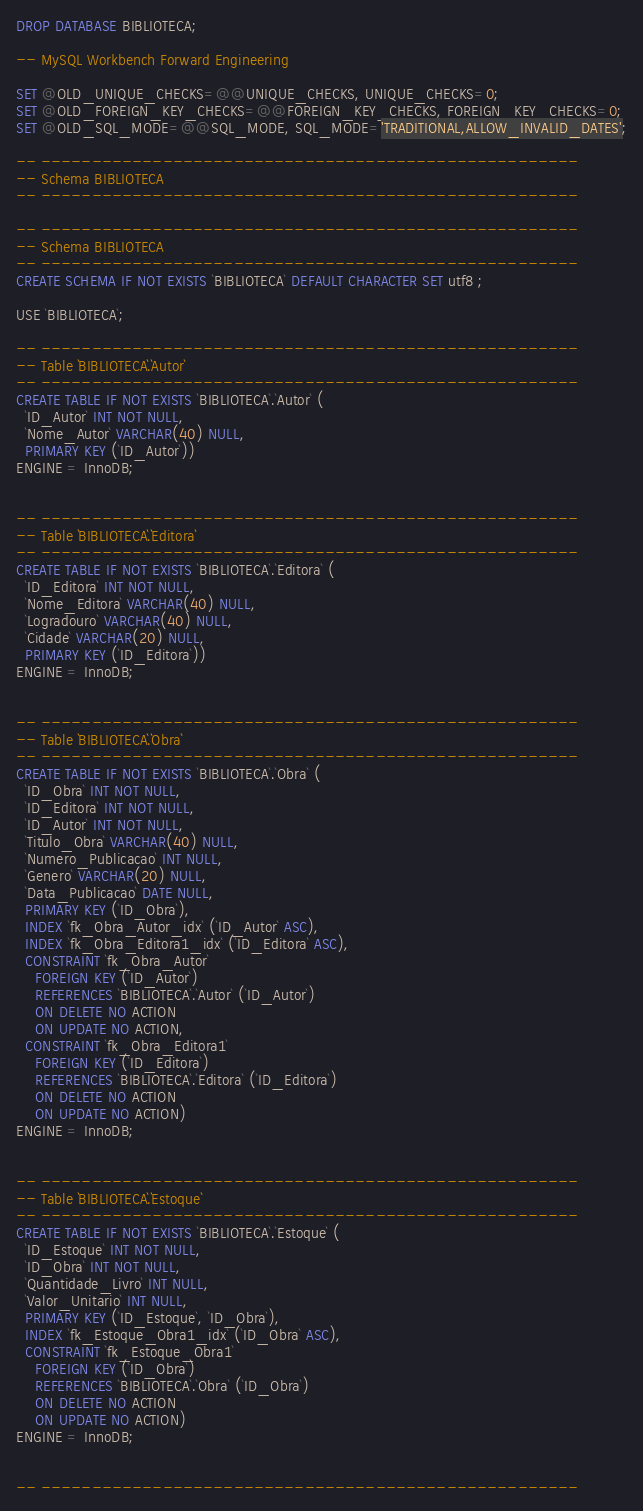Convert code to text. <code><loc_0><loc_0><loc_500><loc_500><_SQL_>DROP DATABASE BIBLIOTECA;

-- MySQL Workbench Forward Engineering

SET @OLD_UNIQUE_CHECKS=@@UNIQUE_CHECKS, UNIQUE_CHECKS=0;
SET @OLD_FOREIGN_KEY_CHECKS=@@FOREIGN_KEY_CHECKS, FOREIGN_KEY_CHECKS=0;
SET @OLD_SQL_MODE=@@SQL_MODE, SQL_MODE='TRADITIONAL,ALLOW_INVALID_DATES';

-- -----------------------------------------------------
-- Schema BIBLIOTECA
-- -----------------------------------------------------

-- -----------------------------------------------------
-- Schema BIBLIOTECA
-- -----------------------------------------------------
CREATE SCHEMA IF NOT EXISTS `BIBLIOTECA` DEFAULT CHARACTER SET utf8 ;

USE `BIBLIOTECA`;

-- -----------------------------------------------------
-- Table `BIBLIOTECA`.`Autor`
-- -----------------------------------------------------
CREATE TABLE IF NOT EXISTS `BIBLIOTECA`.`Autor` (
  `ID_Autor` INT NOT NULL,
  `Nome_Autor` VARCHAR(40) NULL,
  PRIMARY KEY (`ID_Autor`))
ENGINE = InnoDB;


-- -----------------------------------------------------
-- Table `BIBLIOTECA`.`Editora`
-- -----------------------------------------------------
CREATE TABLE IF NOT EXISTS `BIBLIOTECA`.`Editora` (
  `ID_Editora` INT NOT NULL,
  `Nome_Editora` VARCHAR(40) NULL,
  `Logradouro` VARCHAR(40) NULL,
  `Cidade` VARCHAR(20) NULL,
  PRIMARY KEY (`ID_Editora`))
ENGINE = InnoDB;


-- -----------------------------------------------------
-- Table `BIBLIOTECA`.`Obra`
-- -----------------------------------------------------
CREATE TABLE IF NOT EXISTS `BIBLIOTECA`.`Obra` (
  `ID_Obra` INT NOT NULL,
  `ID_Editora` INT NOT NULL,
  `ID_Autor` INT NOT NULL,
  `Titulo_Obra` VARCHAR(40) NULL,
  `Numero_Publicacao` INT NULL,
  `Genero` VARCHAR(20) NULL,
  `Data_Publicacao` DATE NULL,
  PRIMARY KEY (`ID_Obra`),
  INDEX `fk_Obra_Autor_idx` (`ID_Autor` ASC),
  INDEX `fk_Obra_Editora1_idx` (`ID_Editora` ASC),
  CONSTRAINT `fk_Obra_Autor`
    FOREIGN KEY (`ID_Autor`)
    REFERENCES `BIBLIOTECA`.`Autor` (`ID_Autor`)
    ON DELETE NO ACTION
    ON UPDATE NO ACTION,
  CONSTRAINT `fk_Obra_Editora1`
    FOREIGN KEY (`ID_Editora`)
    REFERENCES `BIBLIOTECA`.`Editora` (`ID_Editora`)
    ON DELETE NO ACTION
    ON UPDATE NO ACTION)
ENGINE = InnoDB;


-- -----------------------------------------------------
-- Table `BIBLIOTECA`.`Estoque`
-- -----------------------------------------------------
CREATE TABLE IF NOT EXISTS `BIBLIOTECA`.`Estoque` (
  `ID_Estoque` INT NOT NULL,
  `ID_Obra` INT NOT NULL,
  `Quantidade_Livro` INT NULL,
  `Valor_Unitario` INT NULL,
  PRIMARY KEY (`ID_Estoque`, `ID_Obra`),
  INDEX `fk_Estoque_Obra1_idx` (`ID_Obra` ASC),
  CONSTRAINT `fk_Estoque_Obra1`
    FOREIGN KEY (`ID_Obra`)
    REFERENCES `BIBLIOTECA`.`Obra` (`ID_Obra`)
    ON DELETE NO ACTION
    ON UPDATE NO ACTION)
ENGINE = InnoDB;


-- -----------------------------------------------------</code> 